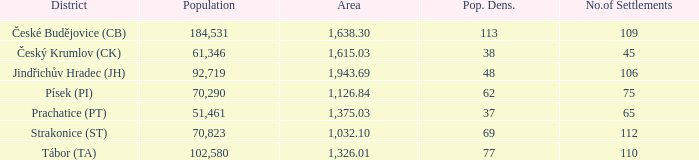What is the population for an area covering 1,126.84? 70290.0. 